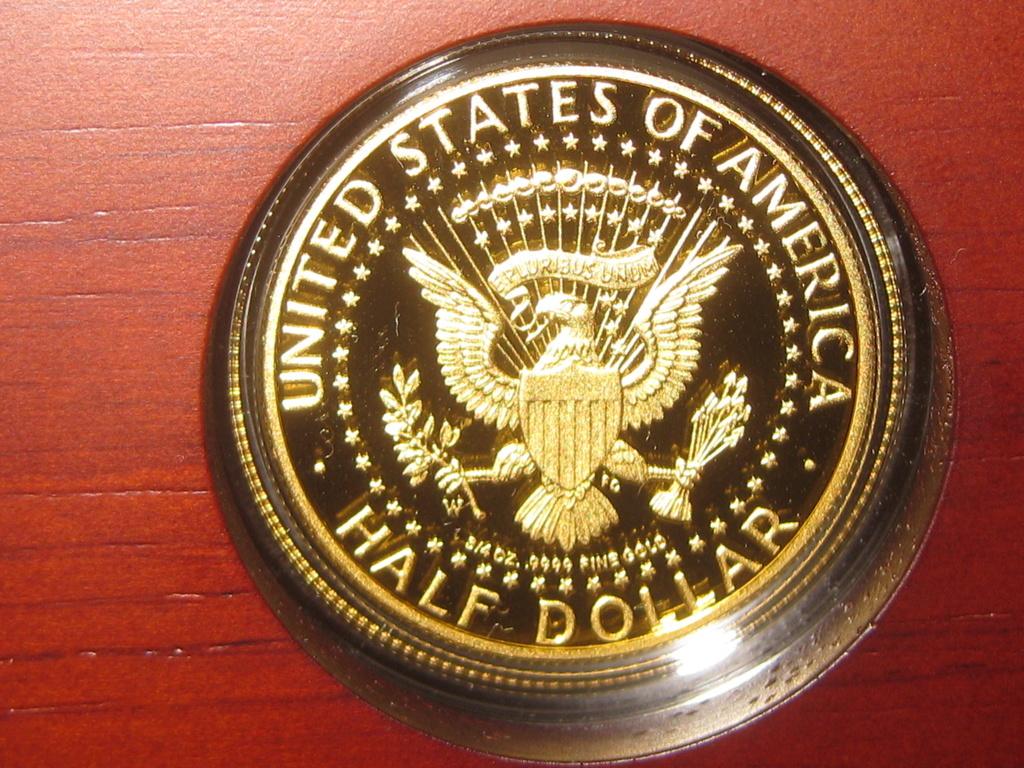What country is mentioned on this half dollar?
Make the answer very short. United states of america. Where is this coin from?
Your answer should be compact. United states of america. 